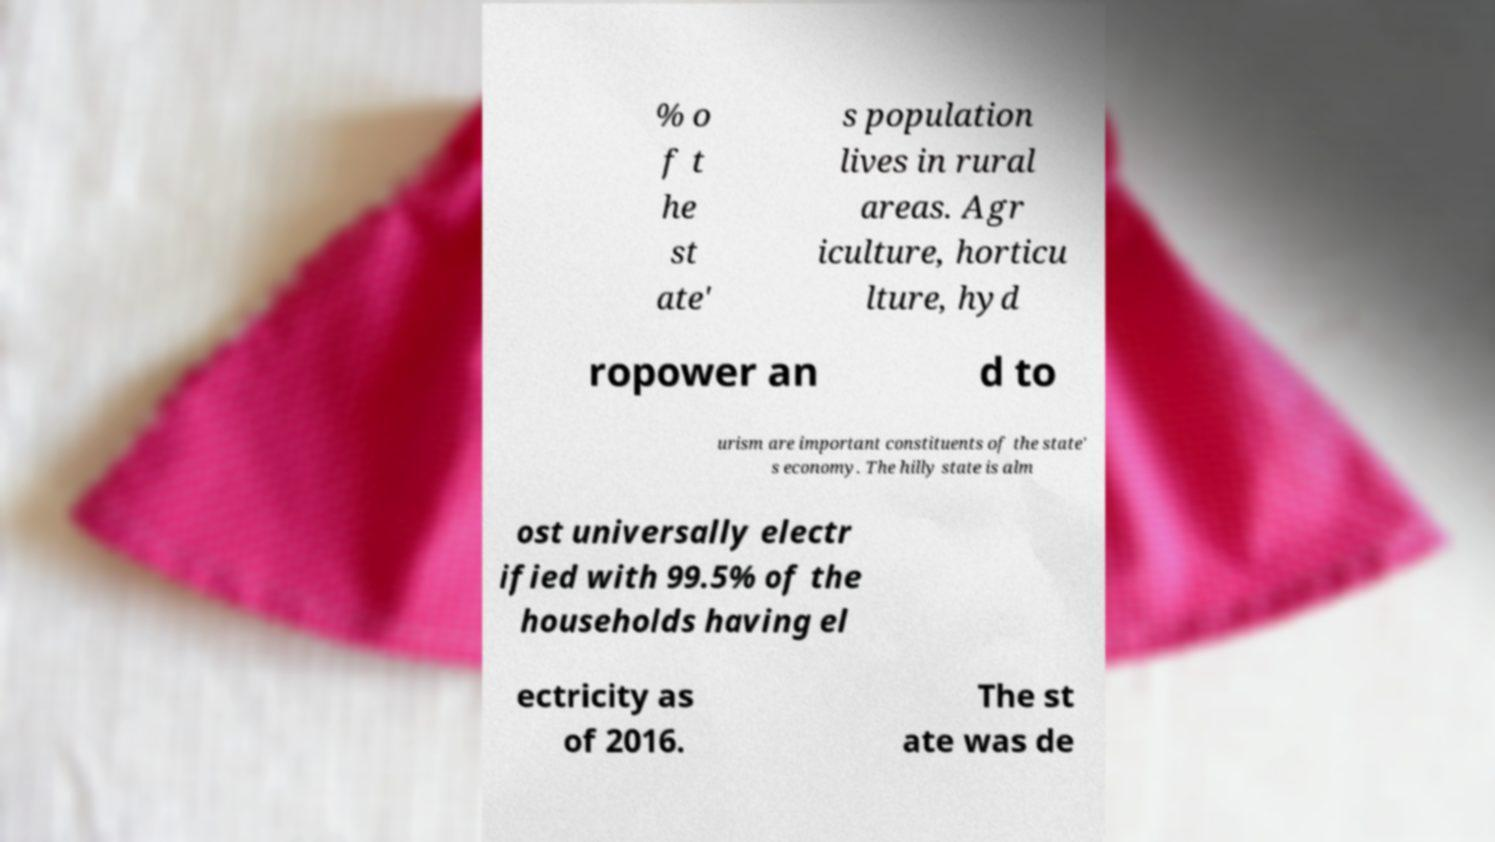What messages or text are displayed in this image? I need them in a readable, typed format. % o f t he st ate' s population lives in rural areas. Agr iculture, horticu lture, hyd ropower an d to urism are important constituents of the state' s economy. The hilly state is alm ost universally electr ified with 99.5% of the households having el ectricity as of 2016. The st ate was de 